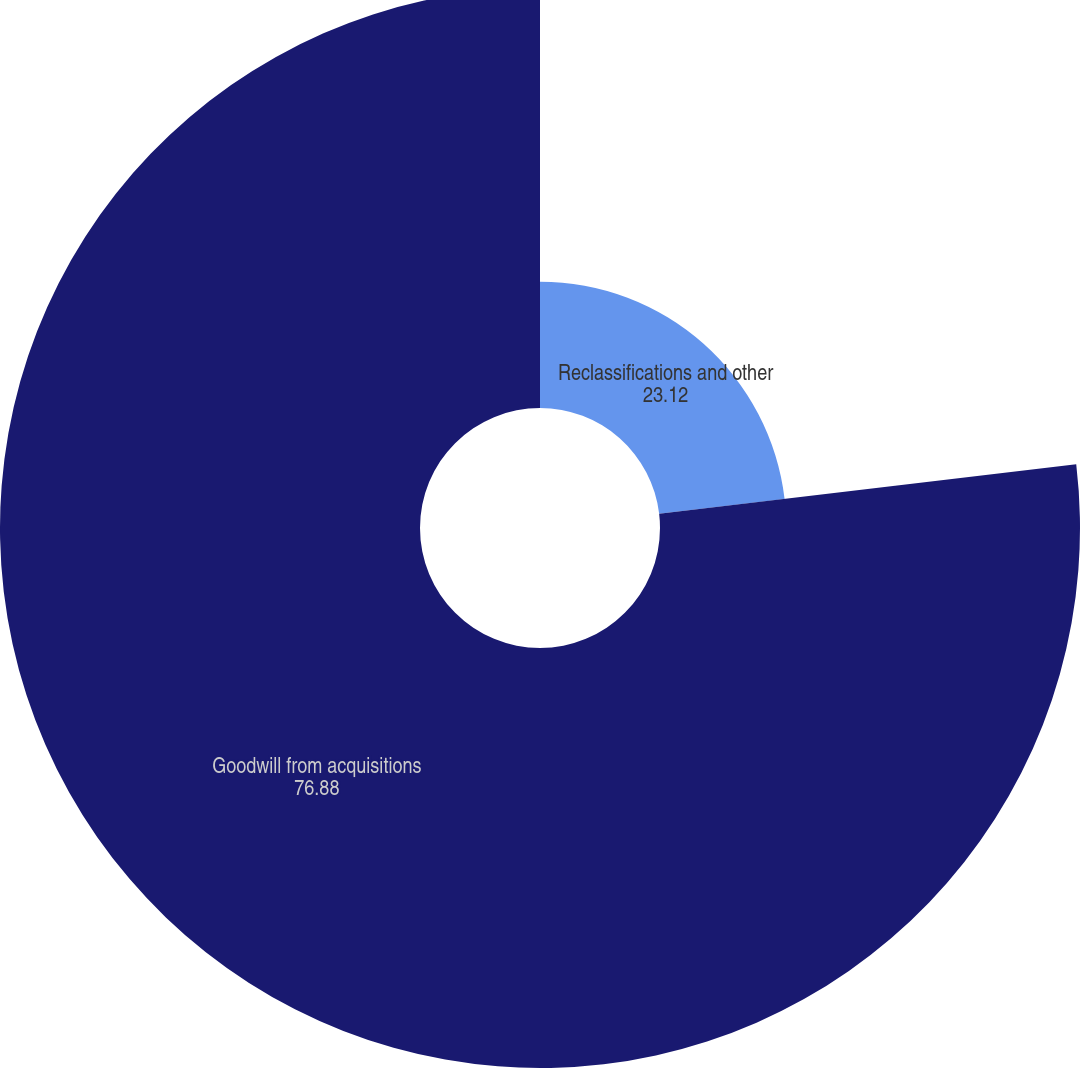<chart> <loc_0><loc_0><loc_500><loc_500><pie_chart><fcel>Reclassifications and other<fcel>Goodwill from acquisitions<nl><fcel>23.12%<fcel>76.88%<nl></chart> 